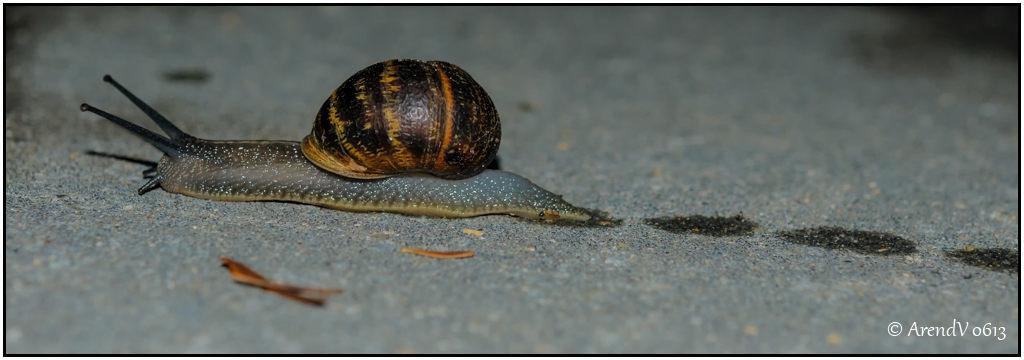What is the focus of the image? The image is zoomed in, so the focus is on a specific area or object. What can be seen on the ground in the image? There is a pond snail on the ground in the image. What is visible in the background of the image? The background of the image includes the ground. Is there any text present in the image? Yes, there is a text on the image in the bottom right corner. What type of corn can be seen growing near the pond snail in the image? There is no corn visible in the image; it only features a pond snail on the ground. How does the jelly interact with the pond snail in the image? There is no jelly present in the image, so it cannot interact with the pond snail. 